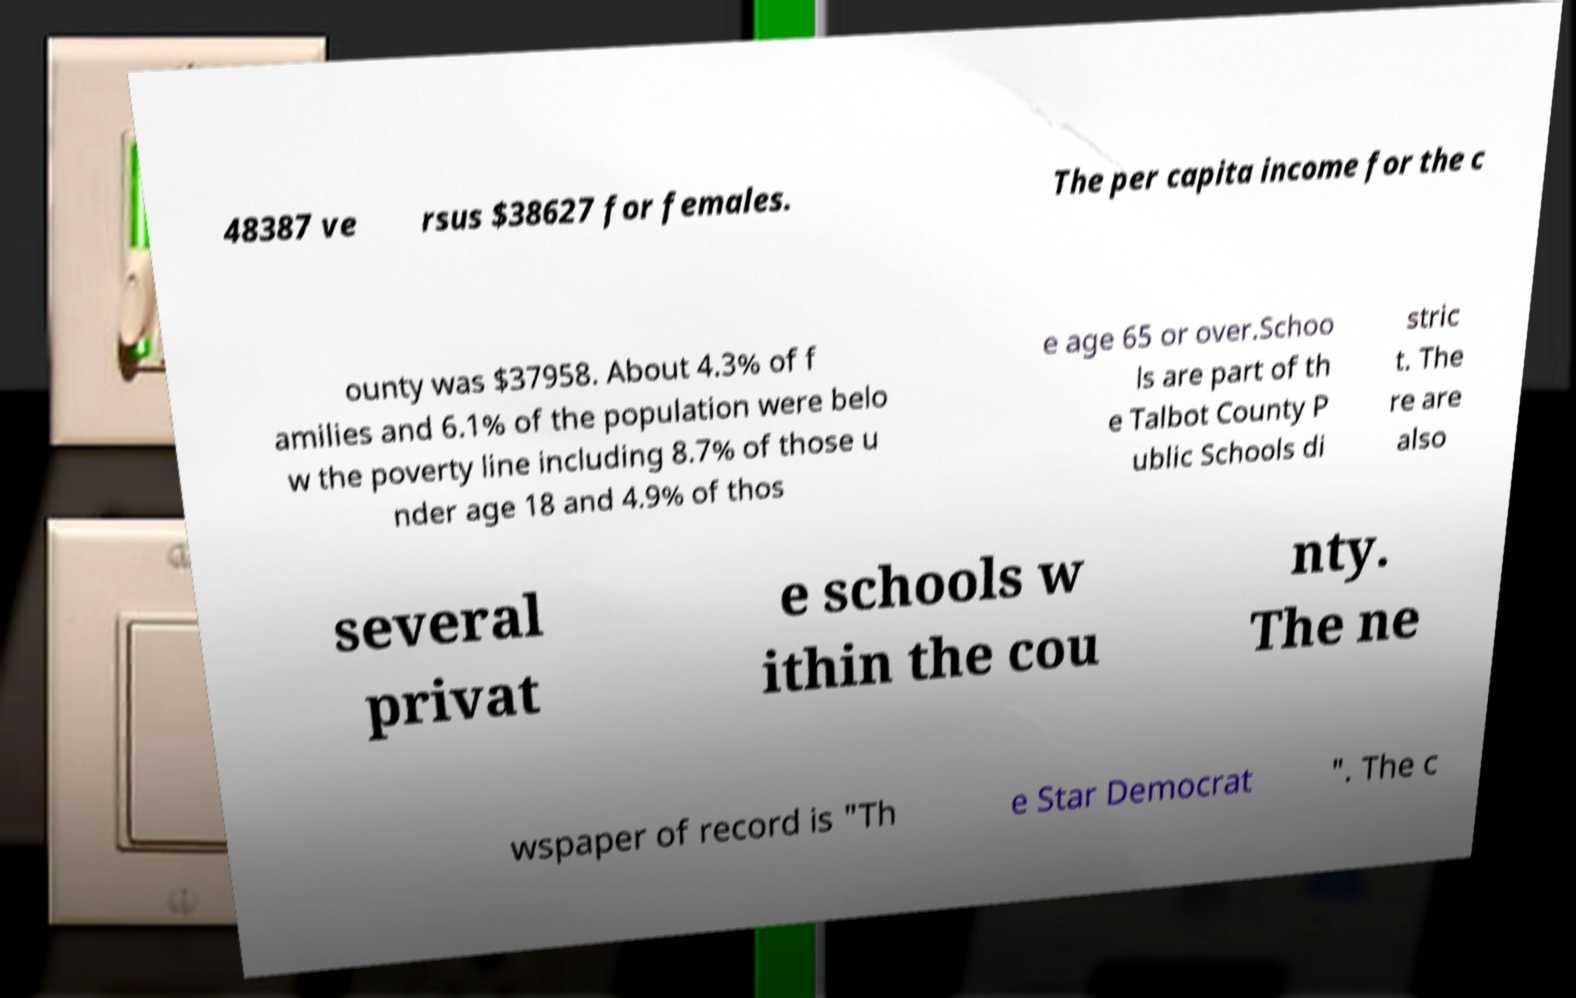For documentation purposes, I need the text within this image transcribed. Could you provide that? 48387 ve rsus $38627 for females. The per capita income for the c ounty was $37958. About 4.3% of f amilies and 6.1% of the population were belo w the poverty line including 8.7% of those u nder age 18 and 4.9% of thos e age 65 or over.Schoo ls are part of th e Talbot County P ublic Schools di stric t. The re are also several privat e schools w ithin the cou nty. The ne wspaper of record is "Th e Star Democrat ". The c 